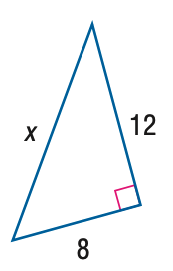Question: Find x.
Choices:
A. 4 \sqrt { 5 }
B. 4 \sqrt { 13 }
C. 8 \sqrt { 5 }
D. 8 \sqrt { 13 }
Answer with the letter. Answer: B 